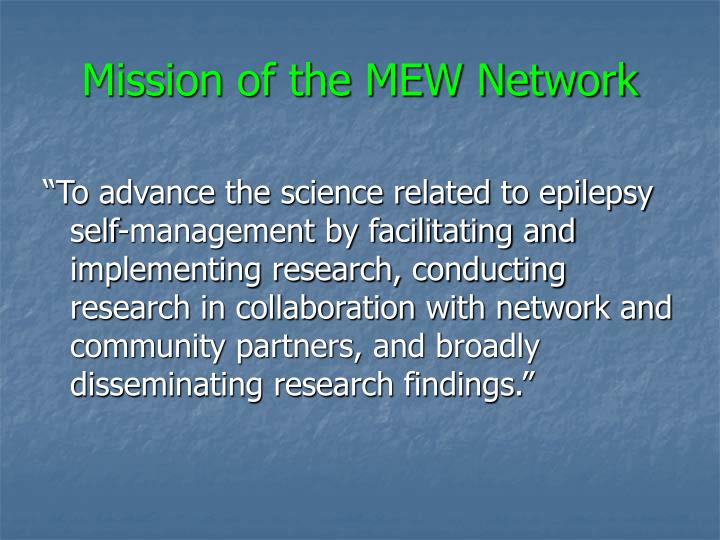How does the MEW Network plan to disseminate their findings to a broader audience? The MEW Network likely employs a variety of dissemination strategies including publishing in scientific journals, presentations at conferences, collaboration with media outlets, and active engagement on social media platforms. They might also run workshops and seminars for patients, caregivers, and healthcare professionals to ensure the findings reach all stakeholders effectively. 